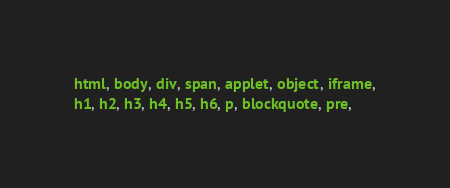Convert code to text. <code><loc_0><loc_0><loc_500><loc_500><_CSS_>html, body, div, span, applet, object, iframe,
h1, h2, h3, h4, h5, h6, p, blockquote, pre,</code> 